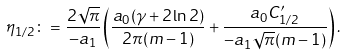Convert formula to latex. <formula><loc_0><loc_0><loc_500><loc_500>\eta _ { 1 / 2 } \colon = \frac { 2 \sqrt { \pi } } { - a _ { 1 } } \left ( \frac { a _ { 0 } ( \gamma + 2 \ln 2 ) } { 2 \pi ( m - 1 ) } + \frac { a _ { 0 } C _ { 1 / 2 } ^ { \prime } } { - a _ { 1 } \sqrt { \pi } ( m - 1 ) } \right ) .</formula> 